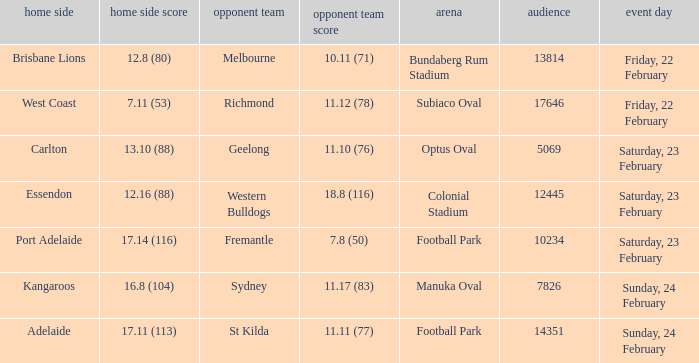What was the score for the visiting team when they played against port adelaide at their home ground? 7.8 (50). 